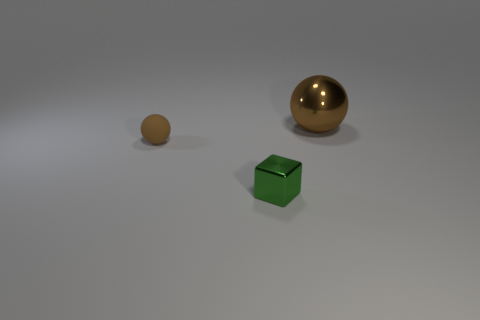Add 1 tiny things. How many objects exist? 4 Subtract all yellow cubes. Subtract all brown cylinders. How many cubes are left? 1 Subtract all spheres. How many objects are left? 1 Add 3 small green things. How many small green things exist? 4 Subtract 0 cyan blocks. How many objects are left? 3 Subtract all rubber objects. Subtract all big spheres. How many objects are left? 1 Add 3 tiny green metallic things. How many tiny green metallic things are left? 4 